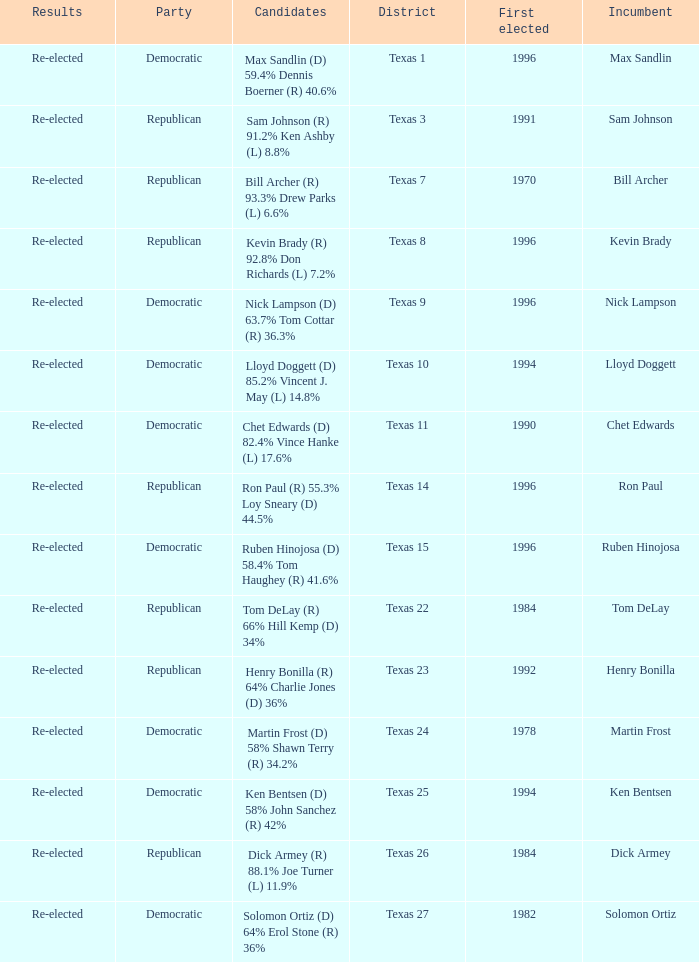What district is ruben hinojosa from? Texas 15. 